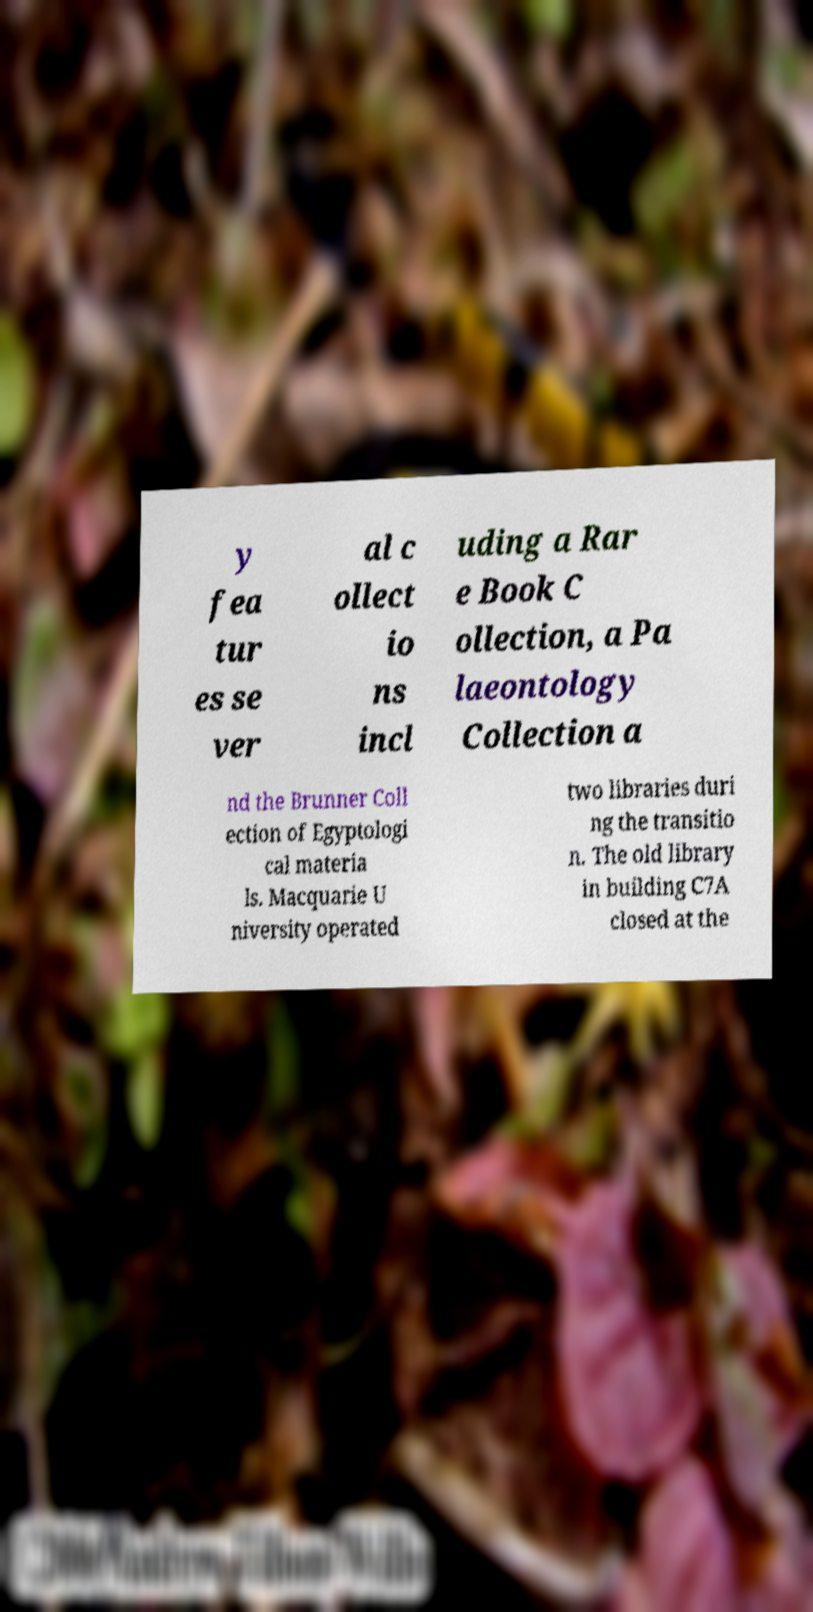Could you assist in decoding the text presented in this image and type it out clearly? y fea tur es se ver al c ollect io ns incl uding a Rar e Book C ollection, a Pa laeontology Collection a nd the Brunner Coll ection of Egyptologi cal materia ls. Macquarie U niversity operated two libraries duri ng the transitio n. The old library in building C7A closed at the 